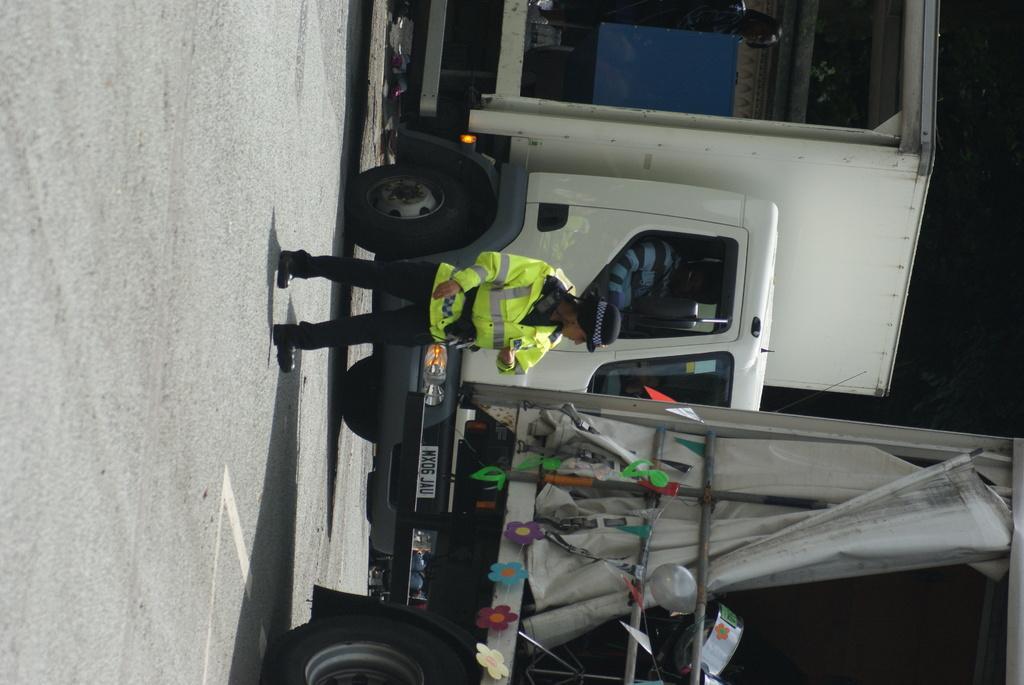Please provide a concise description of this image. There are vehicles and a person on the road. Here we can see a balloon and a cloth. 